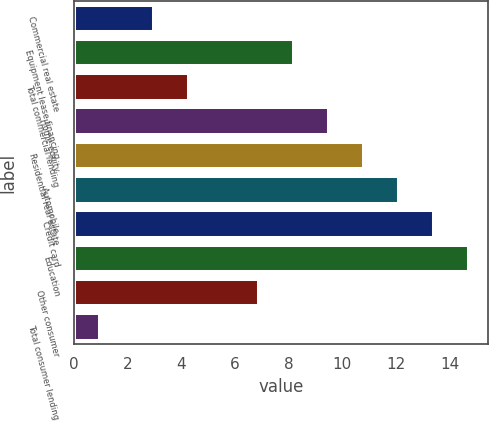Convert chart to OTSL. <chart><loc_0><loc_0><loc_500><loc_500><bar_chart><fcel>Commercial real estate<fcel>Equipment lease financing<fcel>Total commercial lending<fcel>Home equity<fcel>Residential real estate<fcel>Automobile<fcel>Credit card<fcel>Education<fcel>Other consumer<fcel>Total consumer lending<nl><fcel>3<fcel>8.2<fcel>4.3<fcel>9.5<fcel>10.8<fcel>12.1<fcel>13.4<fcel>14.7<fcel>6.9<fcel>1<nl></chart> 